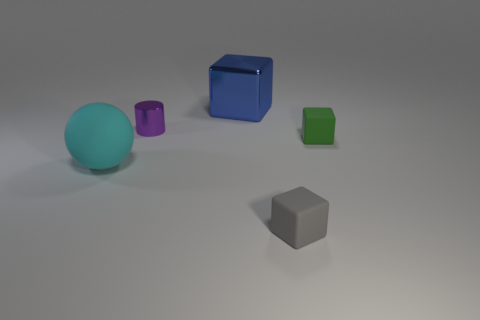Subtract all large metal blocks. How many blocks are left? 2 Subtract all blue blocks. How many blocks are left? 2 Add 3 tiny rubber things. How many objects exist? 8 Subtract 2 cubes. How many cubes are left? 1 Subtract all large things. Subtract all small metal cylinders. How many objects are left? 2 Add 3 gray objects. How many gray objects are left? 4 Add 1 big gray cylinders. How many big gray cylinders exist? 1 Subtract 0 brown blocks. How many objects are left? 5 Subtract all spheres. How many objects are left? 4 Subtract all purple spheres. Subtract all cyan cylinders. How many spheres are left? 1 